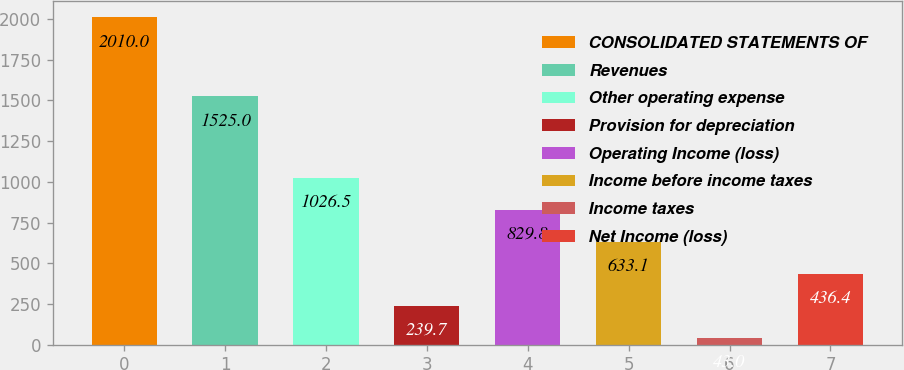Convert chart. <chart><loc_0><loc_0><loc_500><loc_500><bar_chart><fcel>CONSOLIDATED STATEMENTS OF<fcel>Revenues<fcel>Other operating expense<fcel>Provision for depreciation<fcel>Operating Income (loss)<fcel>Income before income taxes<fcel>Income taxes<fcel>Net Income (loss)<nl><fcel>2010<fcel>1525<fcel>1026.5<fcel>239.7<fcel>829.8<fcel>633.1<fcel>43<fcel>436.4<nl></chart> 